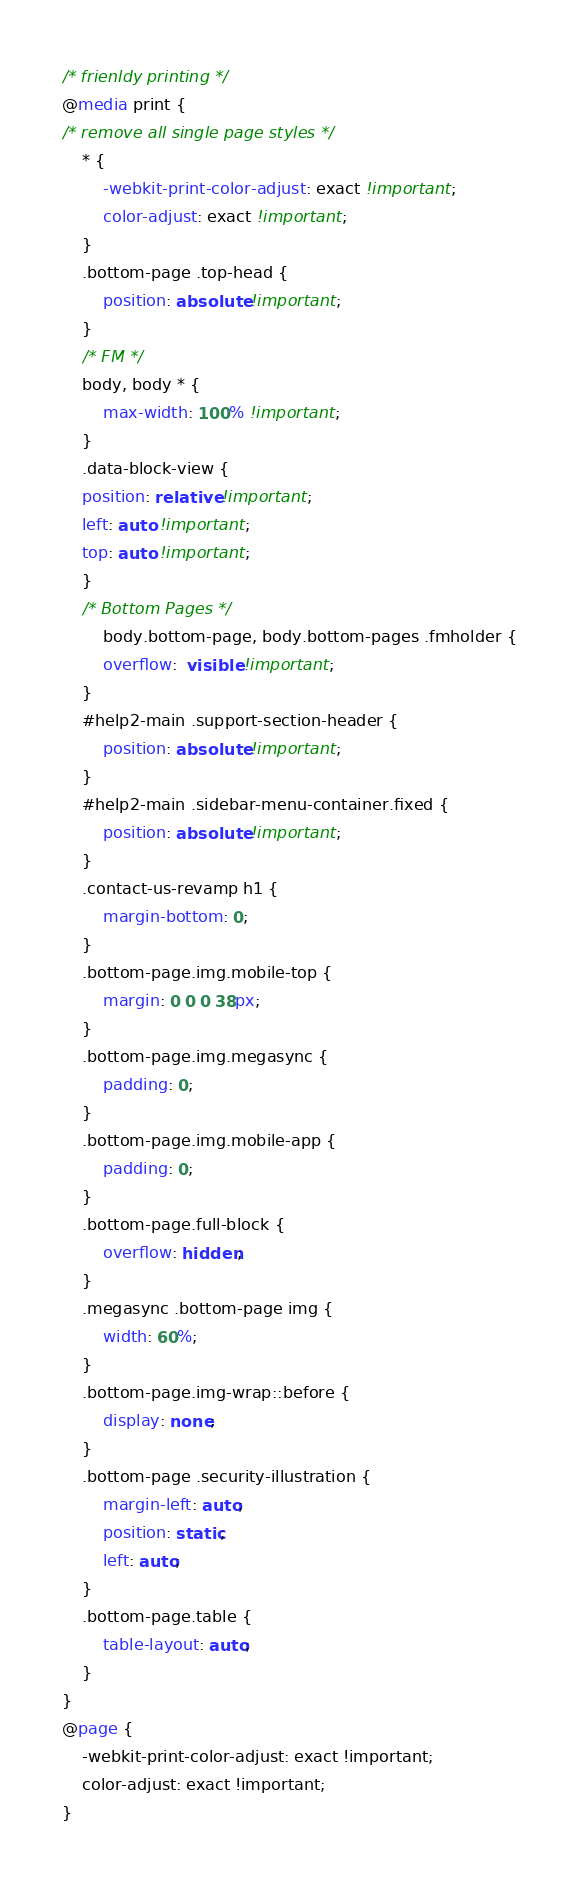<code> <loc_0><loc_0><loc_500><loc_500><_CSS_>/* frienldy printing */
@media print {
/* remove all single page styles */
    * {
        -webkit-print-color-adjust: exact !important;
        color-adjust: exact !important;
    }
    .bottom-page .top-head {
        position: absolute !important;
    }
    /* FM */
    body, body * {
        max-width: 100% !important;
    }
    .data-block-view {
    position: relative !important;
    left: auto !important;
    top: auto !important;
    }
    /* Bottom Pages */
        body.bottom-page, body.bottom-pages .fmholder {
        overflow:  visible !important;
    }
    #help2-main .support-section-header {
        position: absolute !important;
    }
    #help2-main .sidebar-menu-container.fixed {
        position: absolute !important;
    }
    .contact-us-revamp h1 {
        margin-bottom: 0;
    }
    .bottom-page.img.mobile-top {
        margin: 0 0 0 38px;
    }
    .bottom-page.img.megasync {
        padding: 0;
    }
    .bottom-page.img.mobile-app {
        padding: 0;
    }
    .bottom-page.full-block {
        overflow: hidden;
    }
    .megasync .bottom-page img {
        width: 60%;
    }
    .bottom-page.img-wrap::before {
        display: none;
    }
    .bottom-page .security-illustration {
        margin-left: auto;
        position: static; 
        left: auto;
    }
    .bottom-page.table {
        table-layout: auto;
    }
}
@page {
    -webkit-print-color-adjust: exact !important;
    color-adjust: exact !important;
}
</code> 